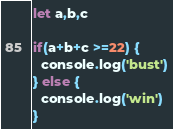<code> <loc_0><loc_0><loc_500><loc_500><_JavaScript_>let a,b,c

if(a+b+c >=22) {
  console.log('bust')
} else {
  console.log('win')
}</code> 